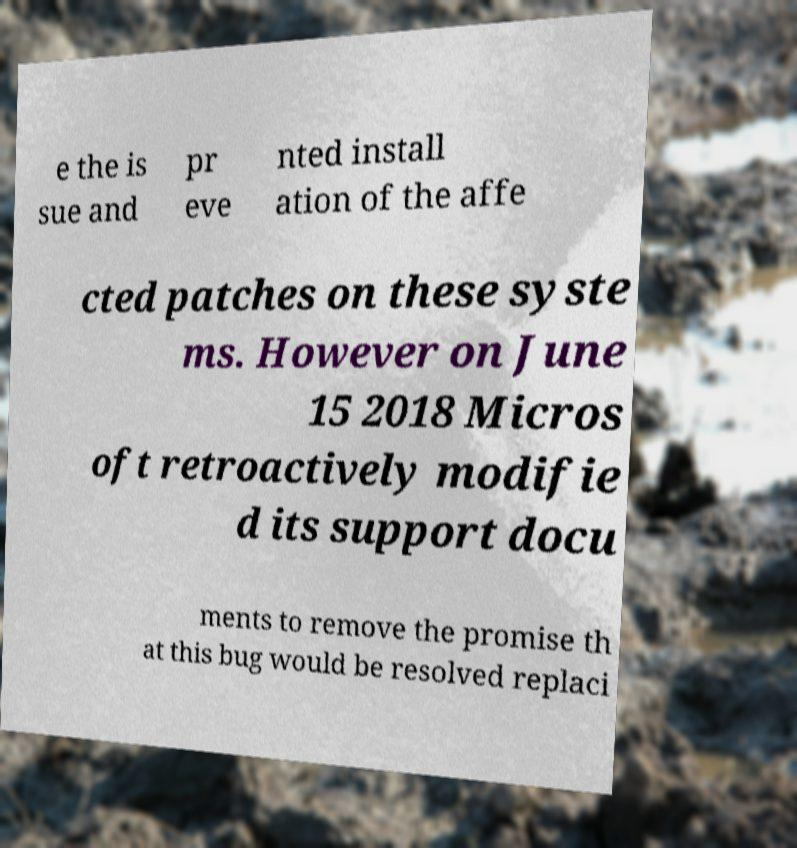Can you accurately transcribe the text from the provided image for me? e the is sue and pr eve nted install ation of the affe cted patches on these syste ms. However on June 15 2018 Micros oft retroactively modifie d its support docu ments to remove the promise th at this bug would be resolved replaci 